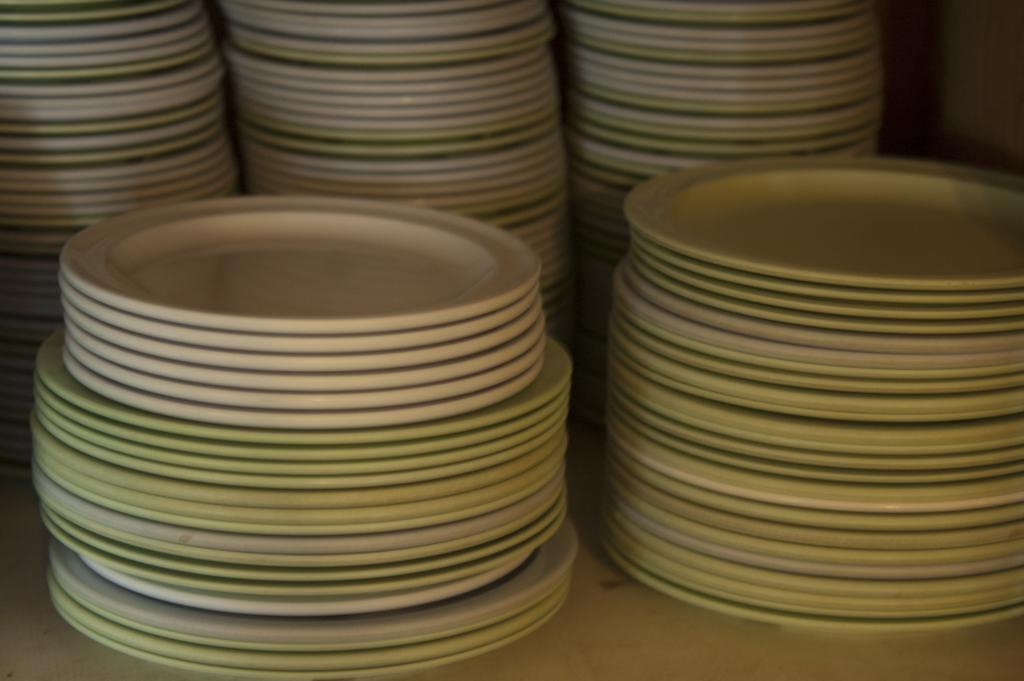What objects can be seen in the image? There are plates in the image. Where are the plates located? The plates are on a surface. What type of minister is present in the image? There is no minister present in the image; it only features plates on a surface. 